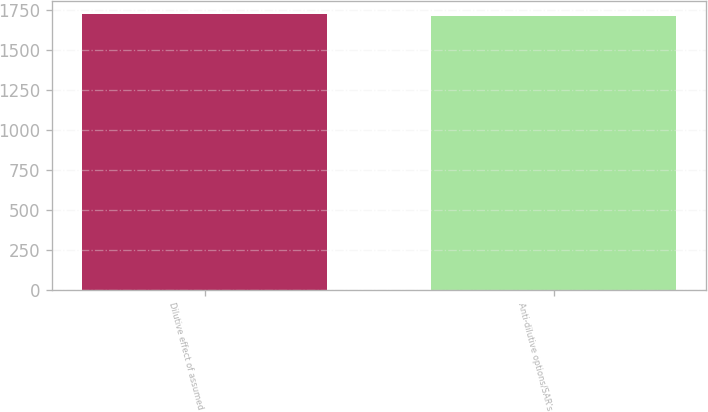Convert chart. <chart><loc_0><loc_0><loc_500><loc_500><bar_chart><fcel>Dilutive effect of assumed<fcel>Anti-dilutive options/SAR's<nl><fcel>1724<fcel>1716<nl></chart> 